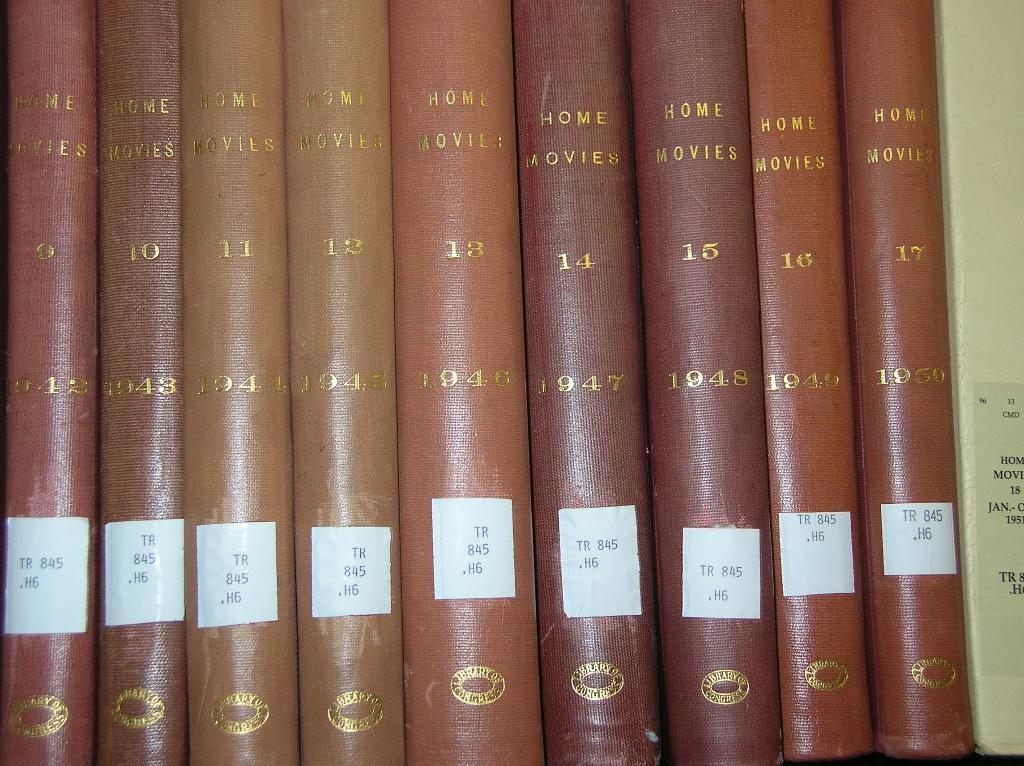<image>
Offer a succinct explanation of the picture presented. A series of leather bound books titled Home Movies 